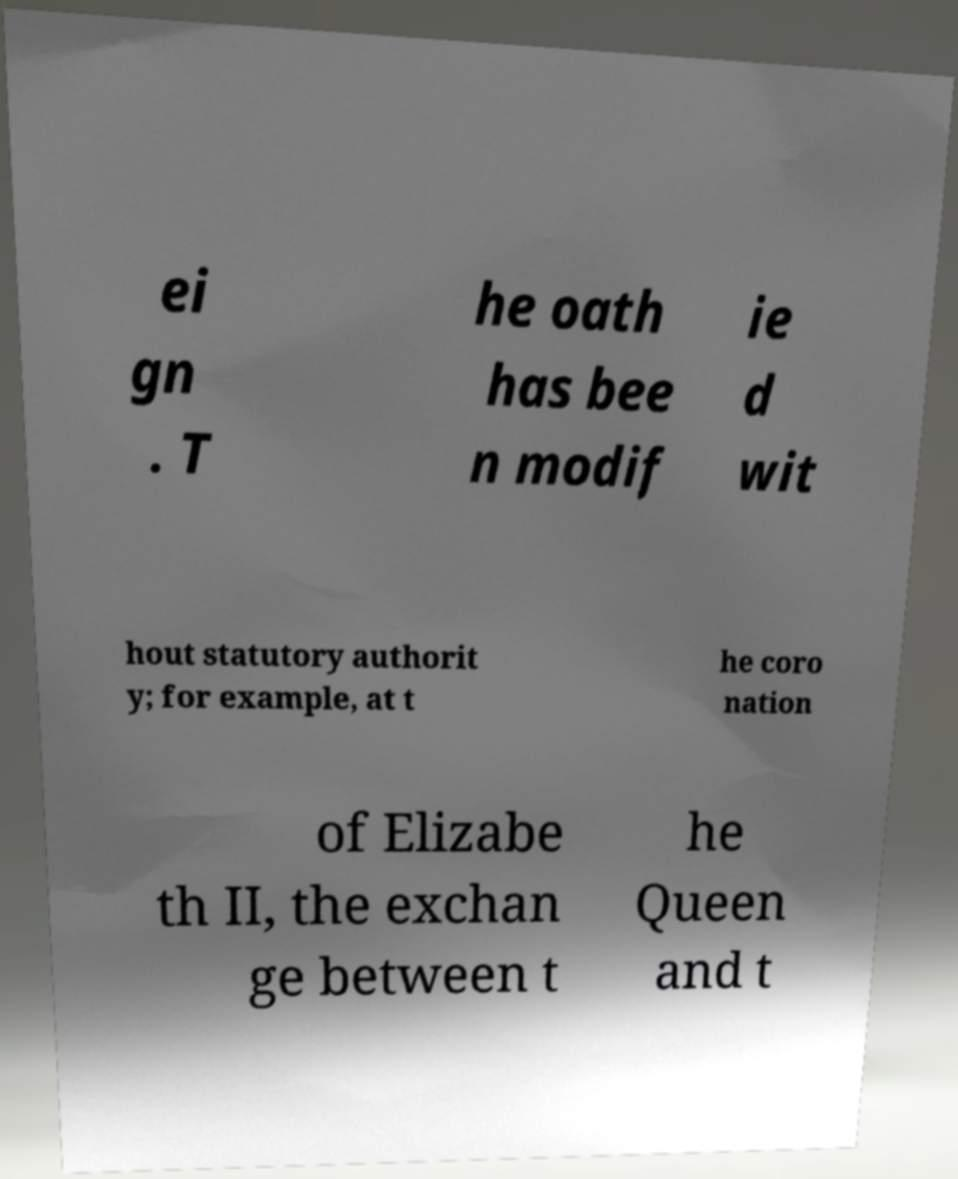Please identify and transcribe the text found in this image. ei gn . T he oath has bee n modif ie d wit hout statutory authorit y; for example, at t he coro nation of Elizabe th II, the exchan ge between t he Queen and t 